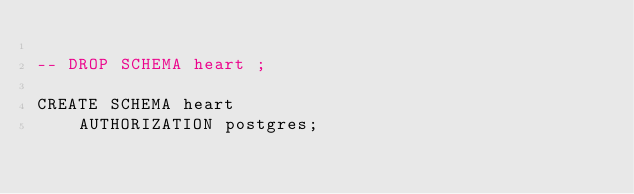<code> <loc_0><loc_0><loc_500><loc_500><_SQL_>
-- DROP SCHEMA heart ;

CREATE SCHEMA heart
    AUTHORIZATION postgres;
</code> 